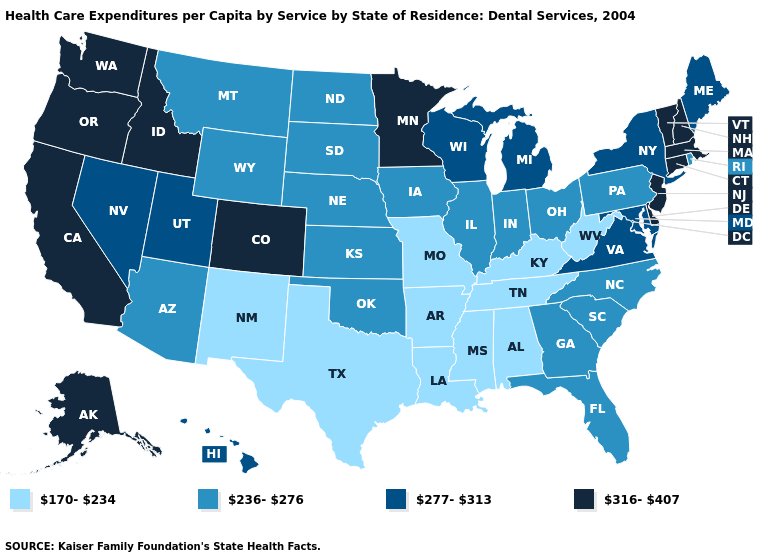Name the states that have a value in the range 170-234?
Quick response, please. Alabama, Arkansas, Kentucky, Louisiana, Mississippi, Missouri, New Mexico, Tennessee, Texas, West Virginia. What is the value of Utah?
Be succinct. 277-313. Name the states that have a value in the range 236-276?
Keep it brief. Arizona, Florida, Georgia, Illinois, Indiana, Iowa, Kansas, Montana, Nebraska, North Carolina, North Dakota, Ohio, Oklahoma, Pennsylvania, Rhode Island, South Carolina, South Dakota, Wyoming. Does the first symbol in the legend represent the smallest category?
Give a very brief answer. Yes. What is the value of New York?
Be succinct. 277-313. Name the states that have a value in the range 316-407?
Give a very brief answer. Alaska, California, Colorado, Connecticut, Delaware, Idaho, Massachusetts, Minnesota, New Hampshire, New Jersey, Oregon, Vermont, Washington. Name the states that have a value in the range 277-313?
Answer briefly. Hawaii, Maine, Maryland, Michigan, Nevada, New York, Utah, Virginia, Wisconsin. Does Iowa have a higher value than Florida?
Be succinct. No. What is the value of Minnesota?
Give a very brief answer. 316-407. Name the states that have a value in the range 277-313?
Write a very short answer. Hawaii, Maine, Maryland, Michigan, Nevada, New York, Utah, Virginia, Wisconsin. Name the states that have a value in the range 316-407?
Write a very short answer. Alaska, California, Colorado, Connecticut, Delaware, Idaho, Massachusetts, Minnesota, New Hampshire, New Jersey, Oregon, Vermont, Washington. Name the states that have a value in the range 170-234?
Answer briefly. Alabama, Arkansas, Kentucky, Louisiana, Mississippi, Missouri, New Mexico, Tennessee, Texas, West Virginia. Name the states that have a value in the range 277-313?
Quick response, please. Hawaii, Maine, Maryland, Michigan, Nevada, New York, Utah, Virginia, Wisconsin. How many symbols are there in the legend?
Answer briefly. 4. Name the states that have a value in the range 170-234?
Be succinct. Alabama, Arkansas, Kentucky, Louisiana, Mississippi, Missouri, New Mexico, Tennessee, Texas, West Virginia. 